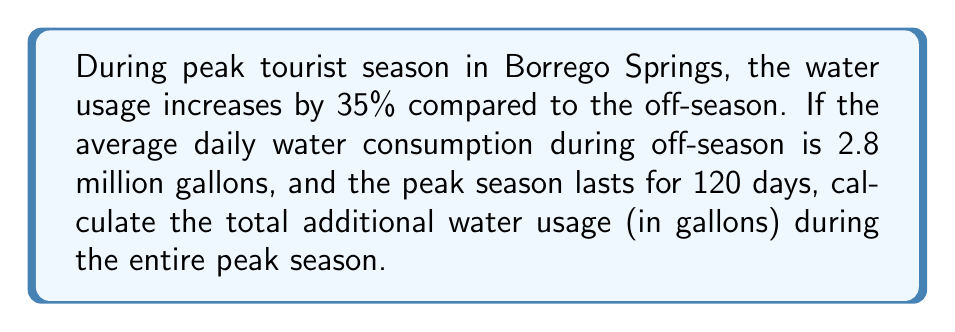Provide a solution to this math problem. Let's approach this step-by-step:

1) First, we need to calculate the daily increase in water usage during peak season:
   $\text{Daily increase} = 35\% \text{ of } 2.8 \text{ million gallons}$
   $= 0.35 \times 2.8 \text{ million gallons}$
   $= 0.98 \text{ million gallons}$

2) Now, we need to calculate this increase over the entire 120-day peak season:
   $\text{Total additional usage} = \text{Daily increase} \times \text{Number of days}$
   $= 0.98 \text{ million gallons} \times 120 \text{ days}$
   $= 117.6 \text{ million gallons}$

3) To convert this to gallons, we multiply by 1 million:
   $117.6 \text{ million gallons} = 117,600,000 \text{ gallons}$

Therefore, the total additional water usage during the entire peak season is 117,600,000 gallons.
Answer: 117,600,000 gallons 